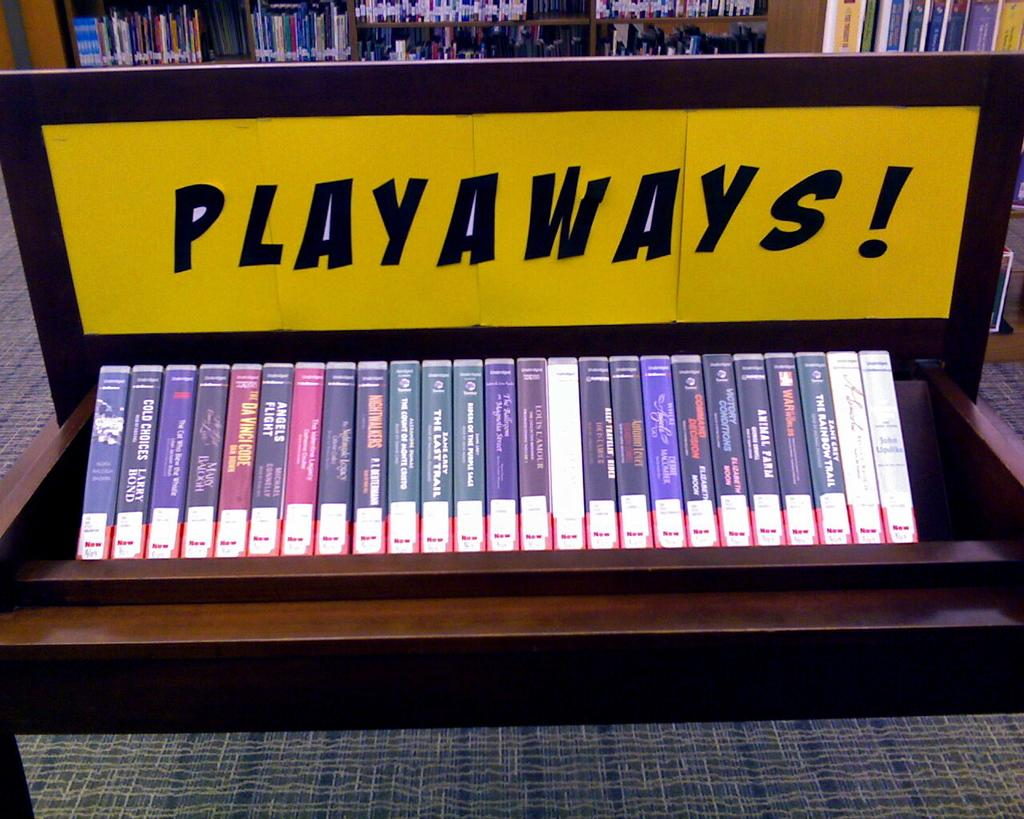<image>
Render a clear and concise summary of the photo. A row of VHS tapes are on a shelf labeled Playaways. 